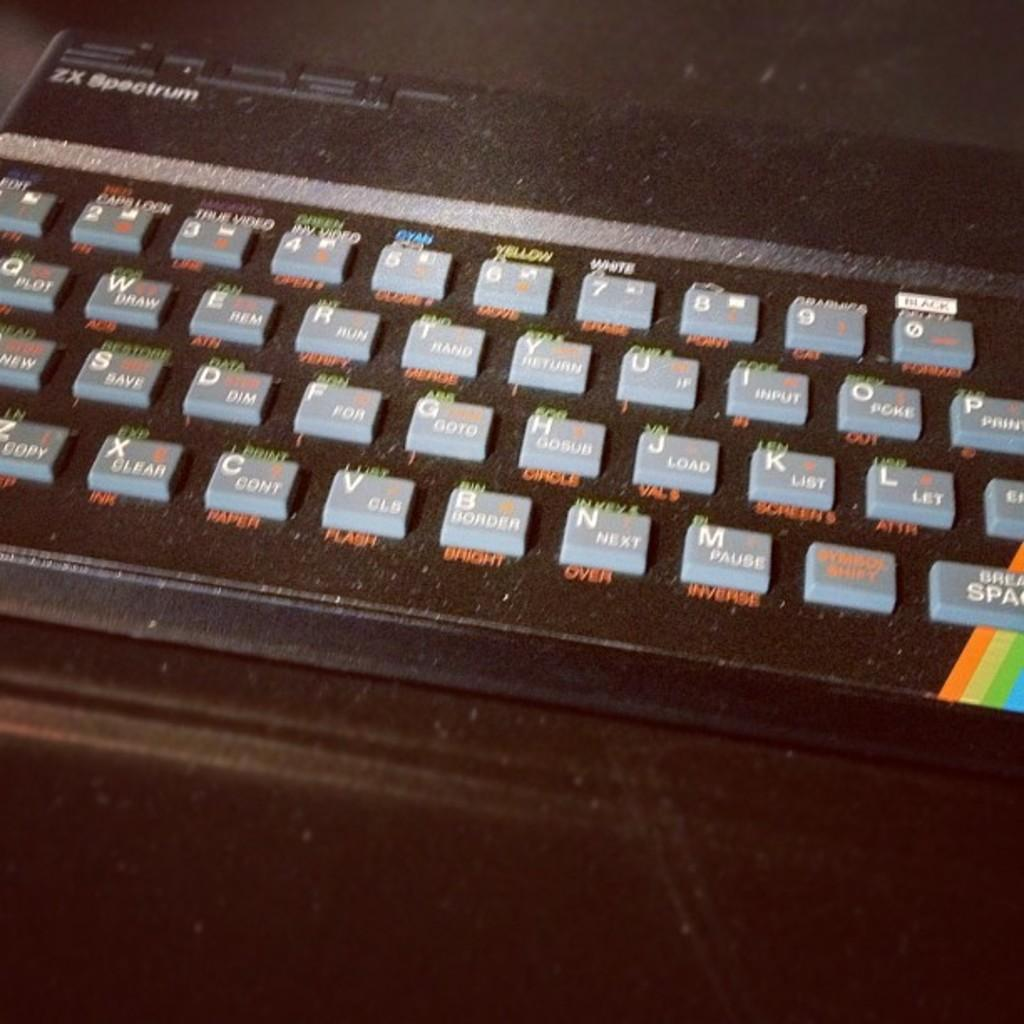<image>
Relay a brief, clear account of the picture shown. A ZX Spectrum keyboard has a rainbow on it. 